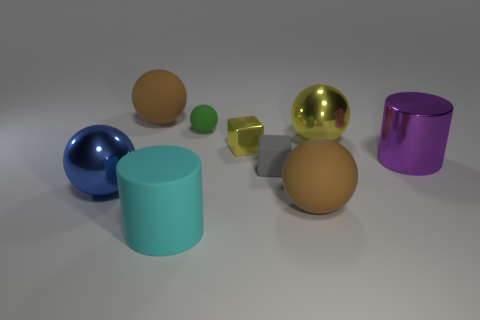Is there a pattern to the arrangement of objects in the image? There doesn't appear to be a strict pattern, but the objects are evenly spaced and none are overlapping, which creates a sense of balance and order within the scene.  What can you tell me about the colors in the image? Do they convey any mood or theme? The image showcases a variety of colors ranging from vibrant to pastel. The blue and golden objects exude a more luxurious feel, while the softer green and brown provide a calming effect. Overall, the color palette is eclectic, contributing to an interesting visual dynamic without conveying a specific mood or theme. 